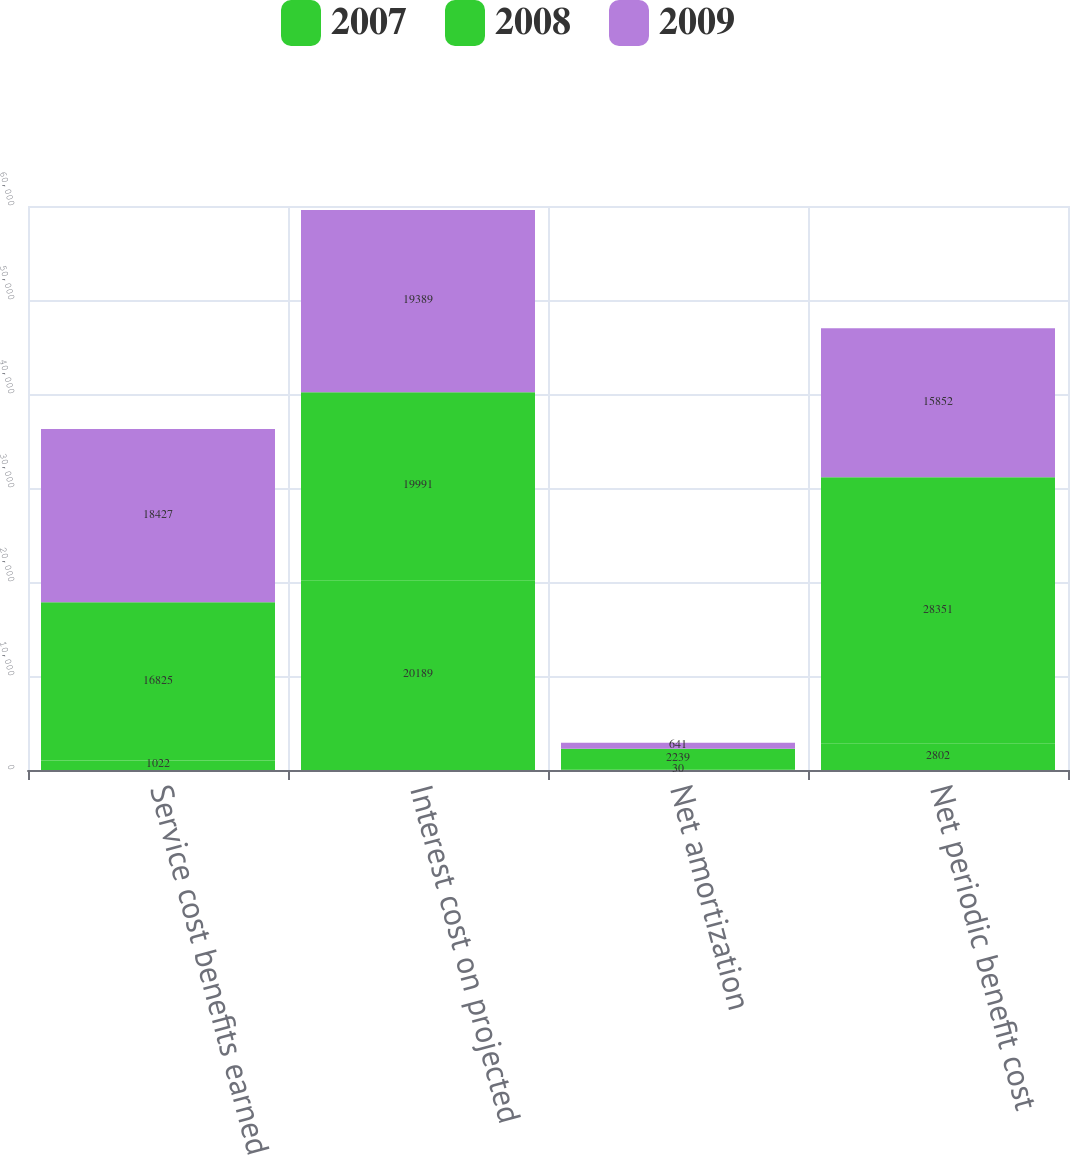Convert chart. <chart><loc_0><loc_0><loc_500><loc_500><stacked_bar_chart><ecel><fcel>Service cost benefits earned<fcel>Interest cost on projected<fcel>Net amortization<fcel>Net periodic benefit cost<nl><fcel>2007<fcel>1022<fcel>20189<fcel>30<fcel>2802<nl><fcel>2008<fcel>16825<fcel>19991<fcel>2239<fcel>28351<nl><fcel>2009<fcel>18427<fcel>19389<fcel>641<fcel>15852<nl></chart> 